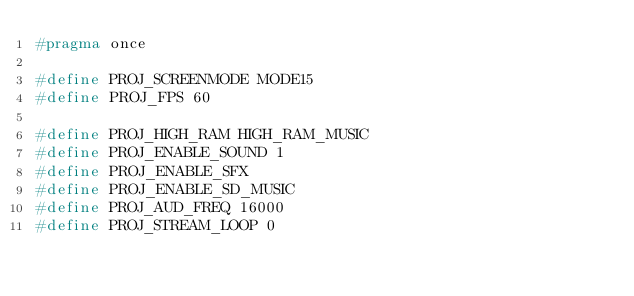Convert code to text. <code><loc_0><loc_0><loc_500><loc_500><_C_>#pragma once

#define PROJ_SCREENMODE MODE15
#define PROJ_FPS 60

#define PROJ_HIGH_RAM HIGH_RAM_MUSIC
#define PROJ_ENABLE_SOUND 1
#define PROJ_ENABLE_SFX
#define PROJ_ENABLE_SD_MUSIC
#define PROJ_AUD_FREQ 16000
#define PROJ_STREAM_LOOP 0

</code> 